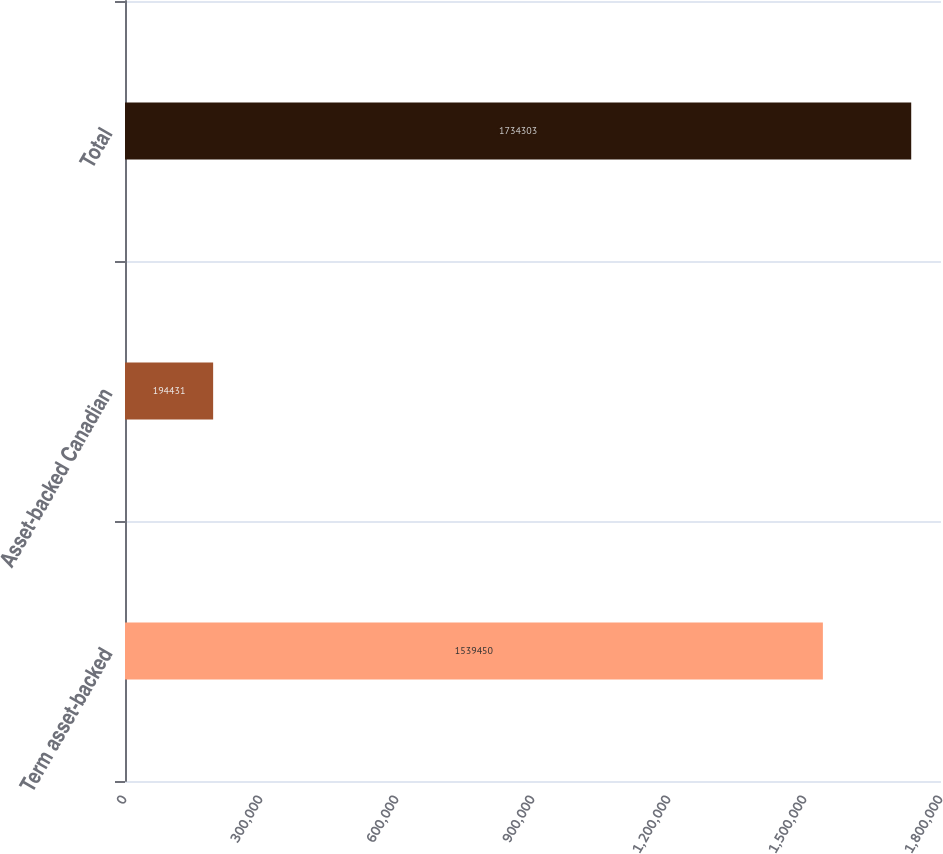<chart> <loc_0><loc_0><loc_500><loc_500><bar_chart><fcel>Term asset-backed<fcel>Asset-backed Canadian<fcel>Total<nl><fcel>1.53945e+06<fcel>194431<fcel>1.7343e+06<nl></chart> 